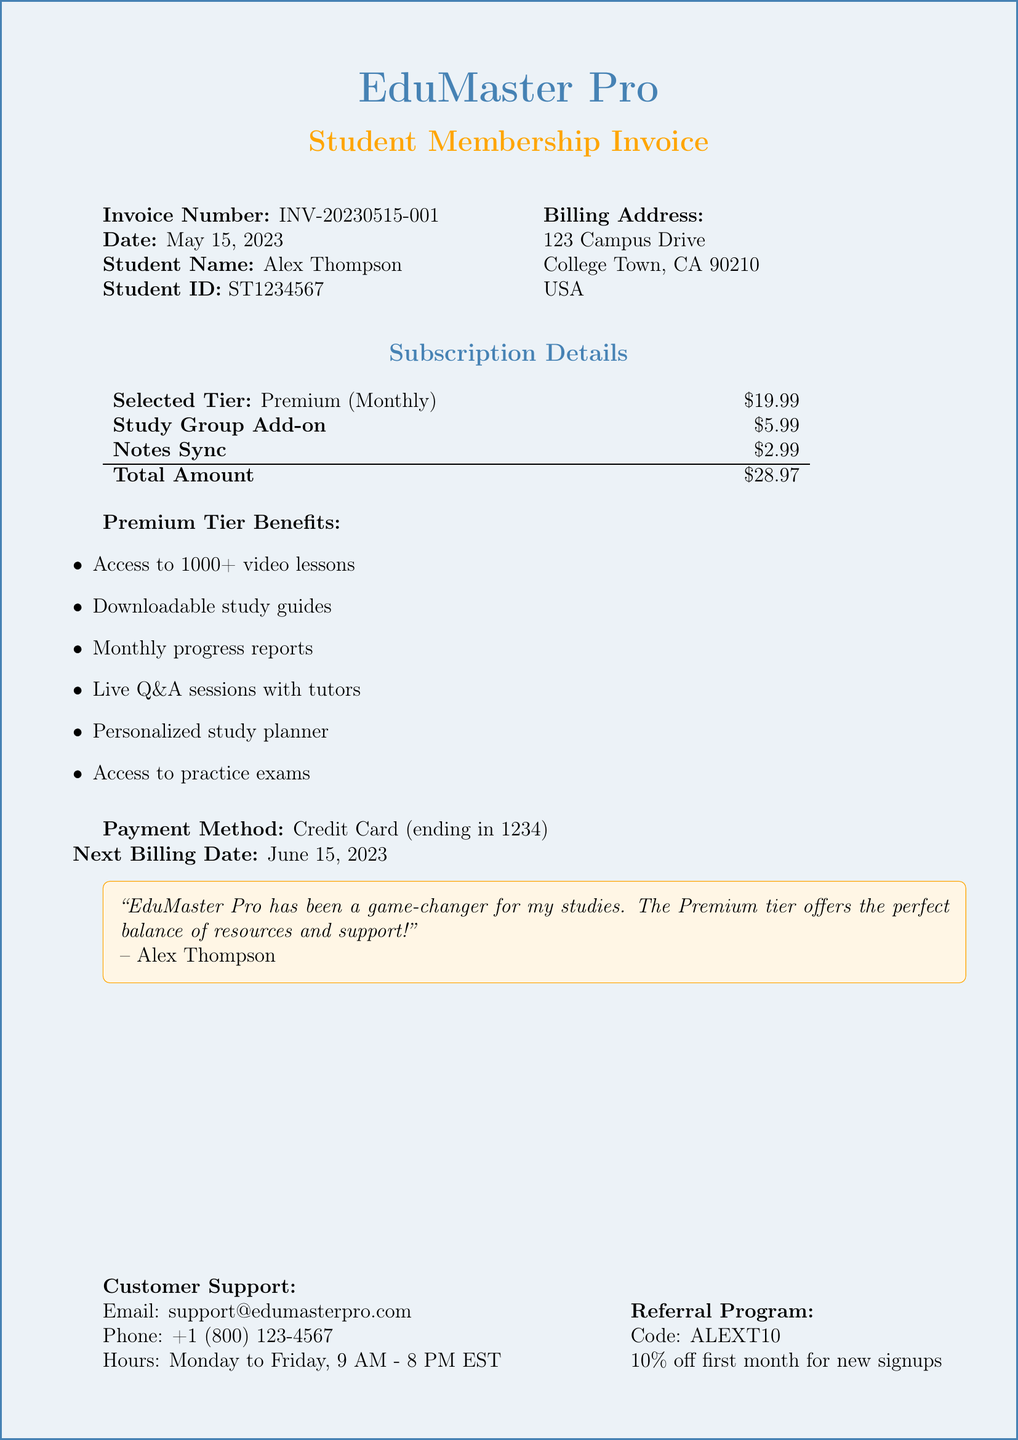What is the invoice number? The invoice number is a unique identifier for the transaction in the document.
Answer: INV-20230515-001 What is the student name? The student's name is provided in the document as part of the billing information.
Answer: Alex Thompson What is the price of the Premium tier? The price of the Premium subscription tier is listed in the document under subscription details.
Answer: 19.99 What benefits are included in the Basic tier? The benefits of the Basic tier are enumerated in the subscription details section.
Answer: Access to 1000+ video lessons, Downloadable study guides, Monthly progress reports What is the total amount due? The total amount due is calculated as the sum of all subscription and additional feature costs.
Answer: 28.97 What is the next billing date? This date indicates when the next payment will be automatically processed, as found in the payment details.
Answer: June 15, 2023 What is the referral code? The referral code provides a discount to new signups, which is explicitly mentioned in the referral program section.
Answer: ALEXT10 How many hours of tutoring are included in the Ultimate Scholar tier? This is part of the benefits detailed under the Ultimate Scholar tier in the document.
Answer: 2 hours/month What is the customer's email for support inquiries? The document includes customer service contact information, specifically for email communication.
Answer: support@edumasterpro.com 